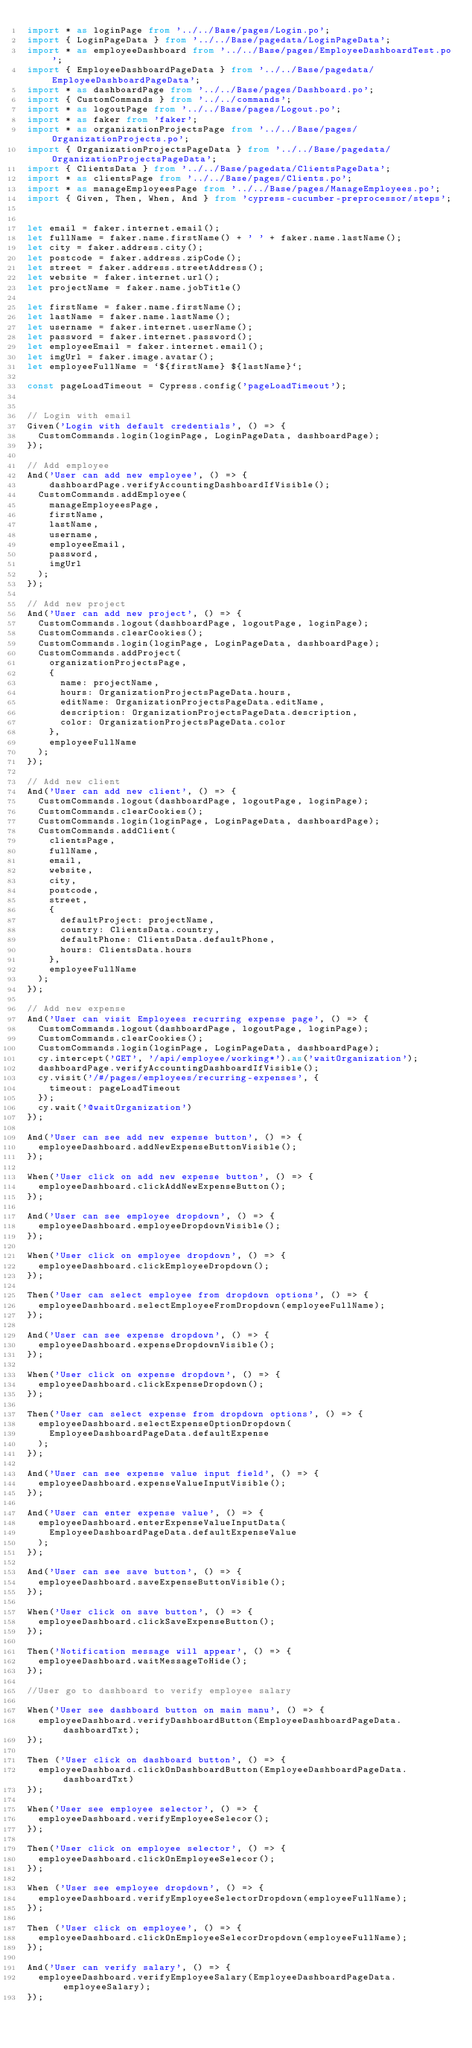<code> <loc_0><loc_0><loc_500><loc_500><_TypeScript_>import * as loginPage from '../../Base/pages/Login.po';
import { LoginPageData } from '../../Base/pagedata/LoginPageData';
import * as employeeDashboard from '../../Base/pages/EmployeeDashboardTest.po';
import { EmployeeDashboardPageData } from '../../Base/pagedata/EmployeeDashboardPageData';
import * as dashboardPage from '../../Base/pages/Dashboard.po';
import { CustomCommands } from '../../commands';
import * as logoutPage from '../../Base/pages/Logout.po';
import * as faker from 'faker';
import * as organizationProjectsPage from '../../Base/pages/OrganizationProjects.po';
import { OrganizationProjectsPageData } from '../../Base/pagedata/OrganizationProjectsPageData';
import { ClientsData } from '../../Base/pagedata/ClientsPageData';
import * as clientsPage from '../../Base/pages/Clients.po';
import * as manageEmployeesPage from '../../Base/pages/ManageEmployees.po';
import { Given, Then, When, And } from 'cypress-cucumber-preprocessor/steps';


let email = faker.internet.email();
let fullName = faker.name.firstName() + ' ' + faker.name.lastName();
let city = faker.address.city();
let postcode = faker.address.zipCode();
let street = faker.address.streetAddress();
let website = faker.internet.url();
let projectName = faker.name.jobTitle()

let firstName = faker.name.firstName();
let lastName = faker.name.lastName();
let username = faker.internet.userName();
let password = faker.internet.password();
let employeeEmail = faker.internet.email();
let imgUrl = faker.image.avatar();
let employeeFullName = `${firstName} ${lastName}`;

const pageLoadTimeout = Cypress.config('pageLoadTimeout');


// Login with email
Given('Login with default credentials', () => {
	CustomCommands.login(loginPage, LoginPageData, dashboardPage);
});

// Add employee
And('User can add new employee', () => {
    dashboardPage.verifyAccountingDashboardIfVisible();
	CustomCommands.addEmployee(
		manageEmployeesPage,
		firstName,
		lastName,
		username,
		employeeEmail,
		password,
		imgUrl
	);
});

// Add new project
And('User can add new project', () => {
	CustomCommands.logout(dashboardPage, logoutPage, loginPage);
	CustomCommands.clearCookies();
	CustomCommands.login(loginPage, LoginPageData, dashboardPage);
	CustomCommands.addProject(
		organizationProjectsPage,
		{
			name: projectName,
			hours: OrganizationProjectsPageData.hours,
			editName: OrganizationProjectsPageData.editName,
			description: OrganizationProjectsPageData.description,
			color: OrganizationProjectsPageData.color
		},
		employeeFullName
	);
});

// Add new client
And('User can add new client', () => {
	CustomCommands.logout(dashboardPage, logoutPage, loginPage);
	CustomCommands.clearCookies();
	CustomCommands.login(loginPage, LoginPageData, dashboardPage);
	CustomCommands.addClient(
		clientsPage,
		fullName,
		email,
		website,
		city,
		postcode,
		street,
		{
			defaultProject: projectName,
			country: ClientsData.country,
			defaultPhone: ClientsData.defaultPhone,
			hours: ClientsData.hours
		},
		employeeFullName
	);
});

// Add new expense
And('User can visit Employees recurring expense page', () => {
	CustomCommands.logout(dashboardPage, logoutPage, loginPage);
	CustomCommands.clearCookies();
	CustomCommands.login(loginPage, LoginPageData, dashboardPage);
	cy.intercept('GET', '/api/employee/working*').as('waitOrganization');
	dashboardPage.verifyAccountingDashboardIfVisible();
	cy.visit('/#/pages/employees/recurring-expenses', {
		timeout: pageLoadTimeout
	});
	cy.wait('@waitOrganization')
});

And('User can see add new expense button', () => {
	employeeDashboard.addNewExpenseButtonVisible();
});

When('User click on add new expense button', () => {
	employeeDashboard.clickAddNewExpenseButton();
});

And('User can see employee dropdown', () => {
	employeeDashboard.employeeDropdownVisible();
});

When('User click on employee dropdown', () => {
	employeeDashboard.clickEmployeeDropdown();
});

Then('User can select employee from dropdown options', () => {
	employeeDashboard.selectEmployeeFromDropdown(employeeFullName);
});

And('User can see expense dropdown', () => {
	employeeDashboard.expenseDropdownVisible();
});

When('User click on expense dropdown', () => {
	employeeDashboard.clickExpenseDropdown();
});

Then('User can select expense from dropdown options', () => {
	employeeDashboard.selectExpenseOptionDropdown(
		EmployeeDashboardPageData.defaultExpense
	);
});

And('User can see expense value input field', () => {
	employeeDashboard.expenseValueInputVisible();
});

And('User can enter expense value', () => {
	employeeDashboard.enterExpenseValueInputData(
		EmployeeDashboardPageData.defaultExpenseValue
	);
});

And('User can see save button', () => {
	employeeDashboard.saveExpenseButtonVisible();
});

When('User click on save button', () => {
	employeeDashboard.clickSaveExpenseButton();
});

Then('Notification message will appear', () => {
	employeeDashboard.waitMessageToHide();
});

//User go to dashboard to verify employee salary

When('User see dashboard button on main manu', () => {
	employeeDashboard.verifyDashboardButton(EmployeeDashboardPageData.dashboardTxt);
});

Then ('User click on dashboard button', () => {
	employeeDashboard.clickOnDashboardButton(EmployeeDashboardPageData.dashboardTxt)
});

When('User see employee selector', () => {
	employeeDashboard.verifyEmployeeSelecor();
});

Then('User click on employee selector', () => {
	employeeDashboard.clickOnEmployeeSelecor();
});

When ('User see employee dropdown', () => {
	employeeDashboard.verifyEmployeeSelectorDropdown(employeeFullName);
});

Then ('User click on employee', () => {
	employeeDashboard.clickOnEmployeeSelecorDropdown(employeeFullName);
});

And('User can verify salary', () => {
	employeeDashboard.verifyEmployeeSalary(EmployeeDashboardPageData.employeeSalary);
});</code> 